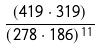Convert formula to latex. <formula><loc_0><loc_0><loc_500><loc_500>\frac { ( 4 1 9 \cdot 3 1 9 ) } { ( 2 7 8 \cdot 1 8 6 ) ^ { 1 1 } }</formula> 